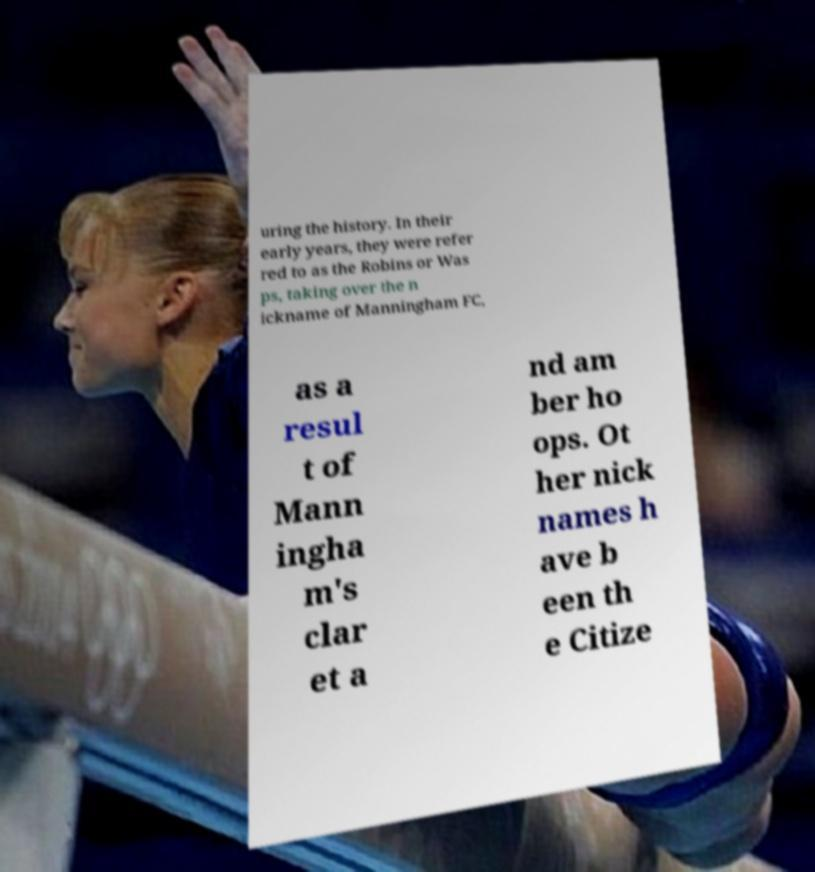What messages or text are displayed in this image? I need them in a readable, typed format. uring the history. In their early years, they were refer red to as the Robins or Was ps, taking over the n ickname of Manningham FC, as a resul t of Mann ingha m's clar et a nd am ber ho ops. Ot her nick names h ave b een th e Citize 